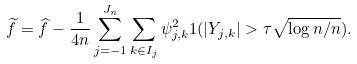<formula> <loc_0><loc_0><loc_500><loc_500>\widetilde { f } = \widehat { f } - \frac { 1 } { 4 n } \sum _ { j = - 1 } ^ { J _ { n } } \sum _ { k \in I _ { j } } \psi _ { j , k } ^ { 2 } 1 ( | Y _ { j , k } | > \tau \sqrt { \log n / n } ) .</formula> 